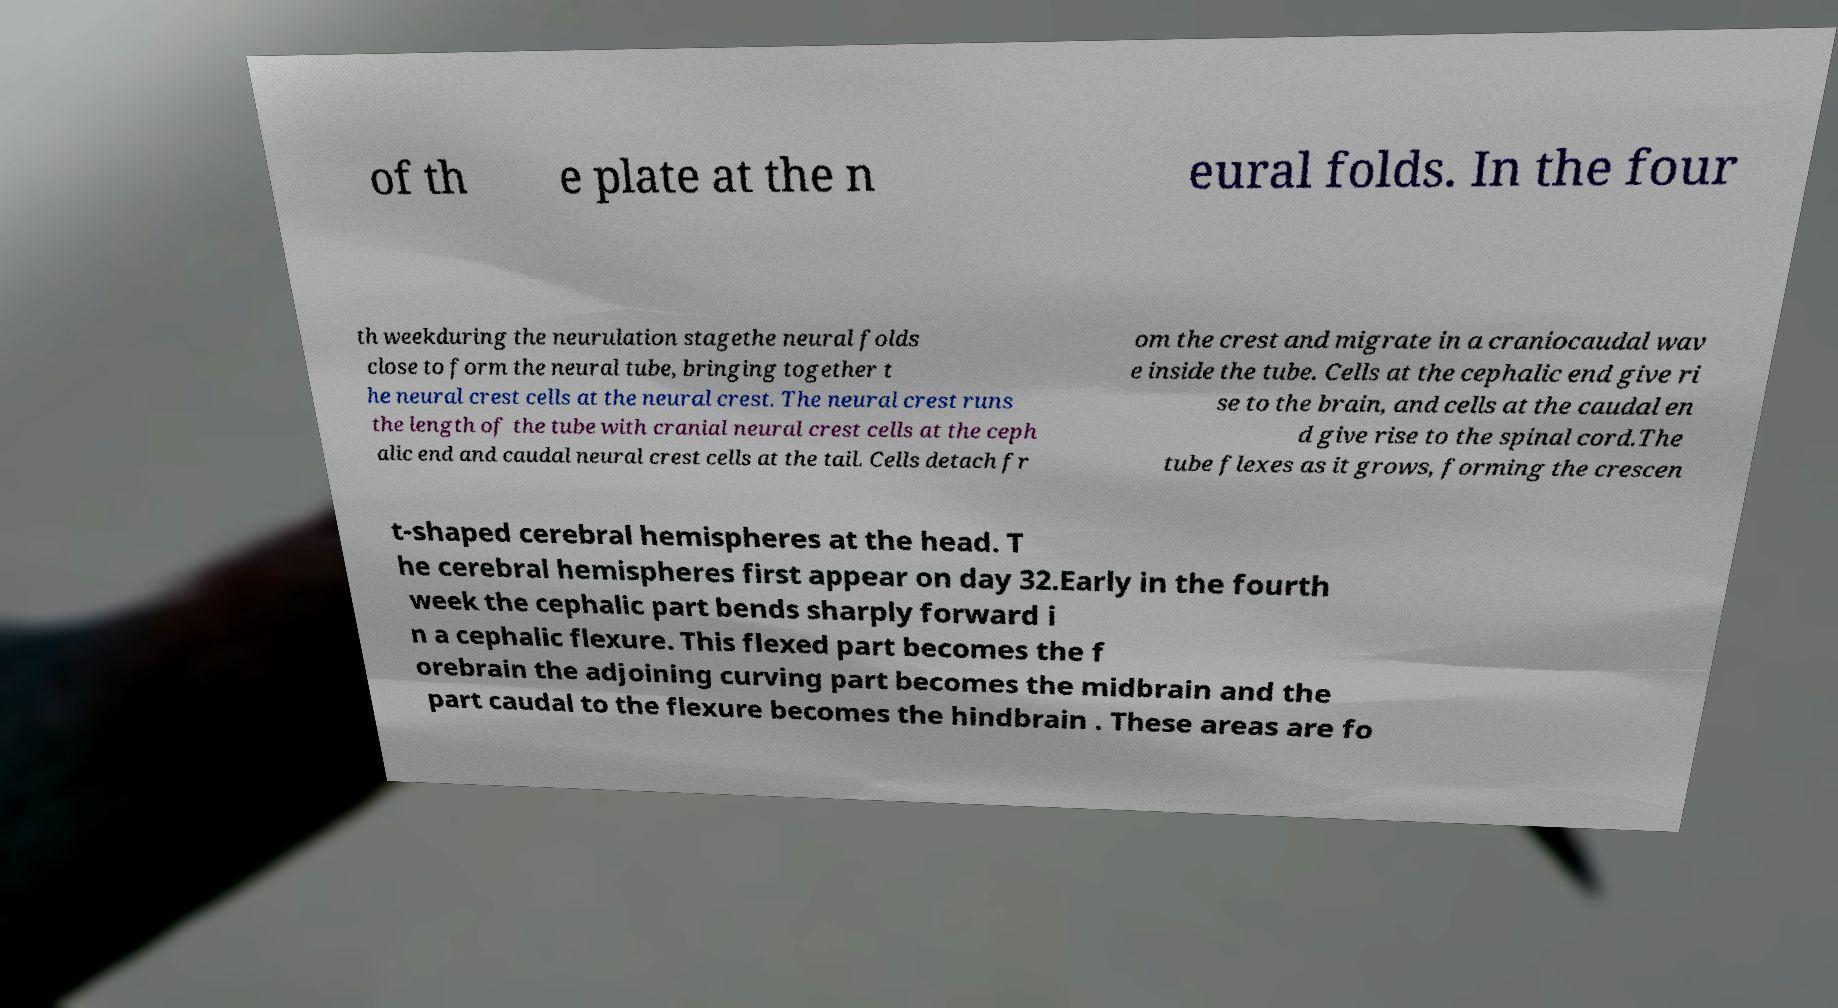What messages or text are displayed in this image? I need them in a readable, typed format. of th e plate at the n eural folds. In the four th weekduring the neurulation stagethe neural folds close to form the neural tube, bringing together t he neural crest cells at the neural crest. The neural crest runs the length of the tube with cranial neural crest cells at the ceph alic end and caudal neural crest cells at the tail. Cells detach fr om the crest and migrate in a craniocaudal wav e inside the tube. Cells at the cephalic end give ri se to the brain, and cells at the caudal en d give rise to the spinal cord.The tube flexes as it grows, forming the crescen t-shaped cerebral hemispheres at the head. T he cerebral hemispheres first appear on day 32.Early in the fourth week the cephalic part bends sharply forward i n a cephalic flexure. This flexed part becomes the f orebrain the adjoining curving part becomes the midbrain and the part caudal to the flexure becomes the hindbrain . These areas are fo 